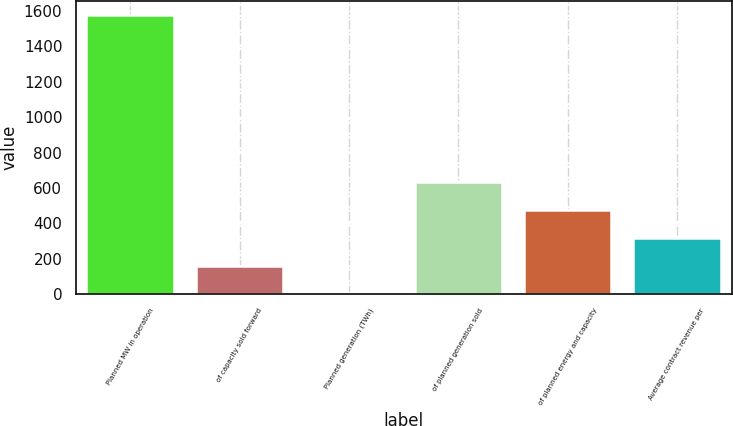Convert chart to OTSL. <chart><loc_0><loc_0><loc_500><loc_500><bar_chart><fcel>Planned MW in operation<fcel>of capacity sold forward<fcel>Planned generation (TWh)<fcel>of planned generation sold<fcel>of planned energy and capacity<fcel>Average contract revenue per<nl><fcel>1578<fcel>161.4<fcel>4<fcel>633.6<fcel>476.2<fcel>318.8<nl></chart> 